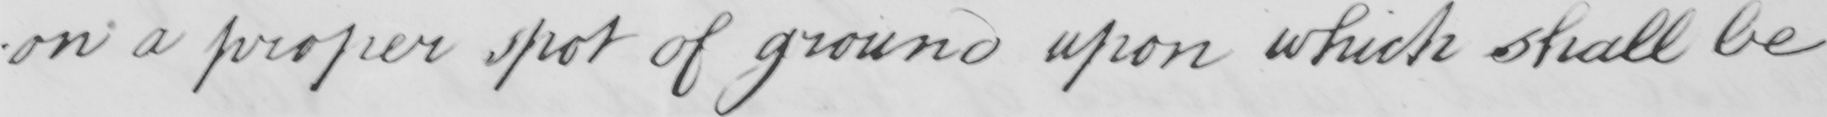Can you read and transcribe this handwriting? -on a proper spot of ground upon which shall be 